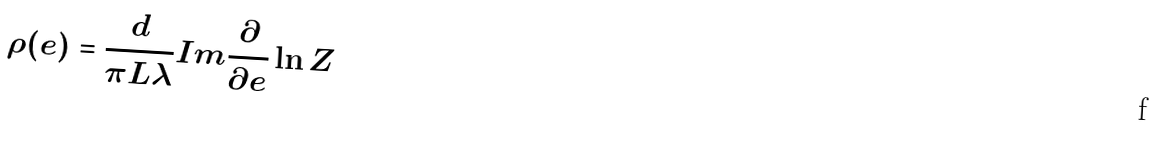<formula> <loc_0><loc_0><loc_500><loc_500>\rho ( e ) = \frac { d } { \pi L \lambda } I m \frac { \partial } { \partial e } \ln Z</formula> 